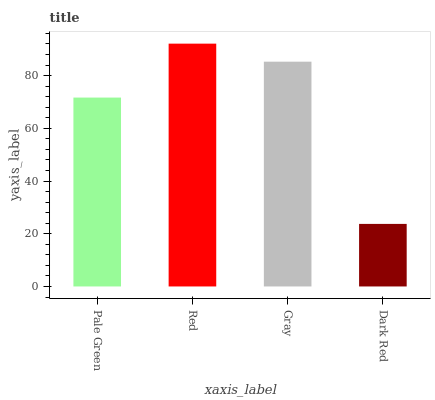Is Dark Red the minimum?
Answer yes or no. Yes. Is Red the maximum?
Answer yes or no. Yes. Is Gray the minimum?
Answer yes or no. No. Is Gray the maximum?
Answer yes or no. No. Is Red greater than Gray?
Answer yes or no. Yes. Is Gray less than Red?
Answer yes or no. Yes. Is Gray greater than Red?
Answer yes or no. No. Is Red less than Gray?
Answer yes or no. No. Is Gray the high median?
Answer yes or no. Yes. Is Pale Green the low median?
Answer yes or no. Yes. Is Red the high median?
Answer yes or no. No. Is Gray the low median?
Answer yes or no. No. 